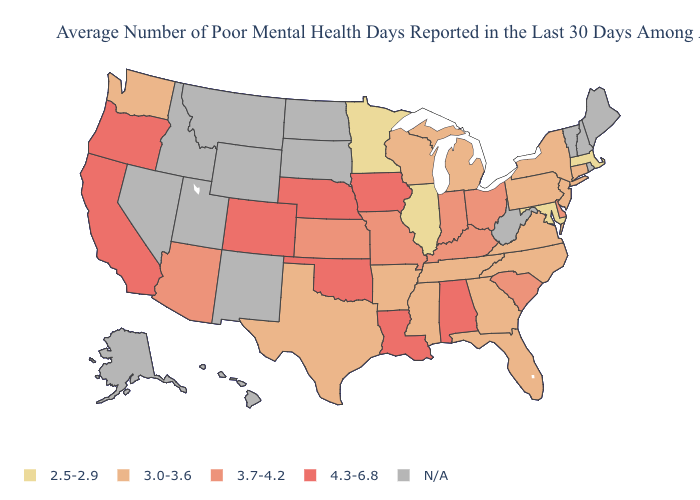What is the highest value in the USA?
Short answer required. 4.3-6.8. What is the value of New York?
Give a very brief answer. 3.0-3.6. What is the value of Kansas?
Give a very brief answer. 3.7-4.2. What is the value of Hawaii?
Keep it brief. N/A. Name the states that have a value in the range 3.0-3.6?
Give a very brief answer. Arkansas, Connecticut, Florida, Georgia, Michigan, Mississippi, New Jersey, New York, North Carolina, Pennsylvania, Tennessee, Texas, Virginia, Washington, Wisconsin. Does the first symbol in the legend represent the smallest category?
Short answer required. Yes. Which states have the lowest value in the USA?
Quick response, please. Illinois, Maryland, Massachusetts, Minnesota. What is the highest value in the South ?
Concise answer only. 4.3-6.8. What is the highest value in the USA?
Keep it brief. 4.3-6.8. Among the states that border Oregon , does Washington have the highest value?
Keep it brief. No. What is the highest value in the USA?
Keep it brief. 4.3-6.8. What is the highest value in states that border Oregon?
Concise answer only. 4.3-6.8. Does Iowa have the highest value in the USA?
Be succinct. Yes. 